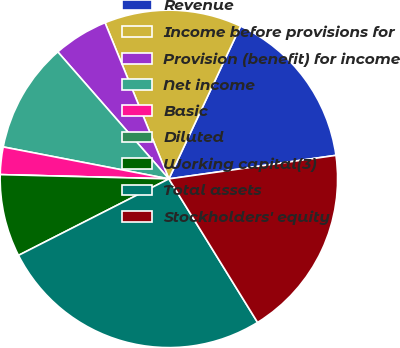Convert chart to OTSL. <chart><loc_0><loc_0><loc_500><loc_500><pie_chart><fcel>Revenue<fcel>Income before provisions for<fcel>Provision (benefit) for income<fcel>Net income<fcel>Basic<fcel>Diluted<fcel>Working capital(3)<fcel>Total assets<fcel>Stockholders' equity<nl><fcel>15.79%<fcel>13.16%<fcel>5.26%<fcel>10.53%<fcel>2.63%<fcel>0.0%<fcel>7.89%<fcel>26.32%<fcel>18.42%<nl></chart> 